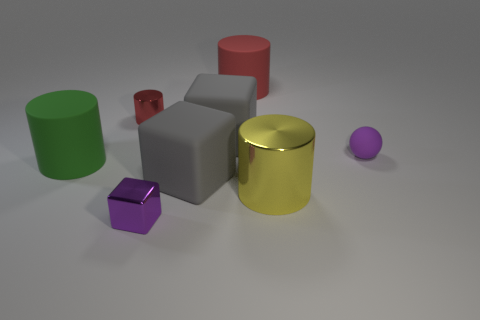Subtract all yellow shiny cylinders. How many cylinders are left? 3 Subtract all blue cylinders. How many gray cubes are left? 2 Add 1 tiny shiny blocks. How many objects exist? 9 Subtract 1 cylinders. How many cylinders are left? 3 Subtract all balls. How many objects are left? 7 Subtract all green cylinders. How many cylinders are left? 3 Subtract all red cubes. Subtract all blue spheres. How many cubes are left? 3 Subtract all big gray cubes. Subtract all big red matte objects. How many objects are left? 5 Add 8 big gray objects. How many big gray objects are left? 10 Add 4 blue rubber cylinders. How many blue rubber cylinders exist? 4 